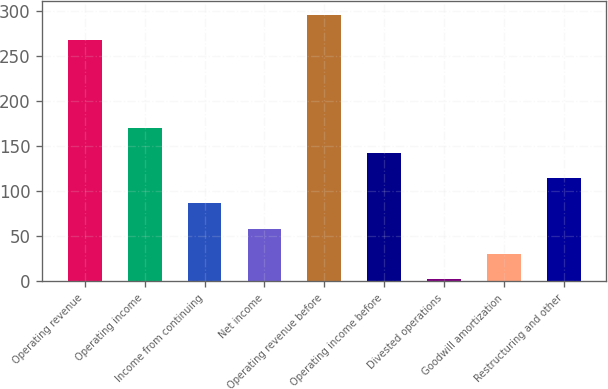<chart> <loc_0><loc_0><loc_500><loc_500><bar_chart><fcel>Operating revenue<fcel>Operating income<fcel>Income from continuing<fcel>Net income<fcel>Operating revenue before<fcel>Operating income before<fcel>Divested operations<fcel>Goodwill amortization<fcel>Restructuring and other<nl><fcel>268<fcel>169.96<fcel>86.38<fcel>58.52<fcel>295.86<fcel>142.1<fcel>2.8<fcel>30.66<fcel>114.24<nl></chart> 